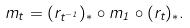Convert formula to latex. <formula><loc_0><loc_0><loc_500><loc_500>m _ { t } = ( r _ { t ^ { - 1 } } ) _ { * } \circ m _ { 1 } \circ ( r _ { t } ) _ { * } .</formula> 